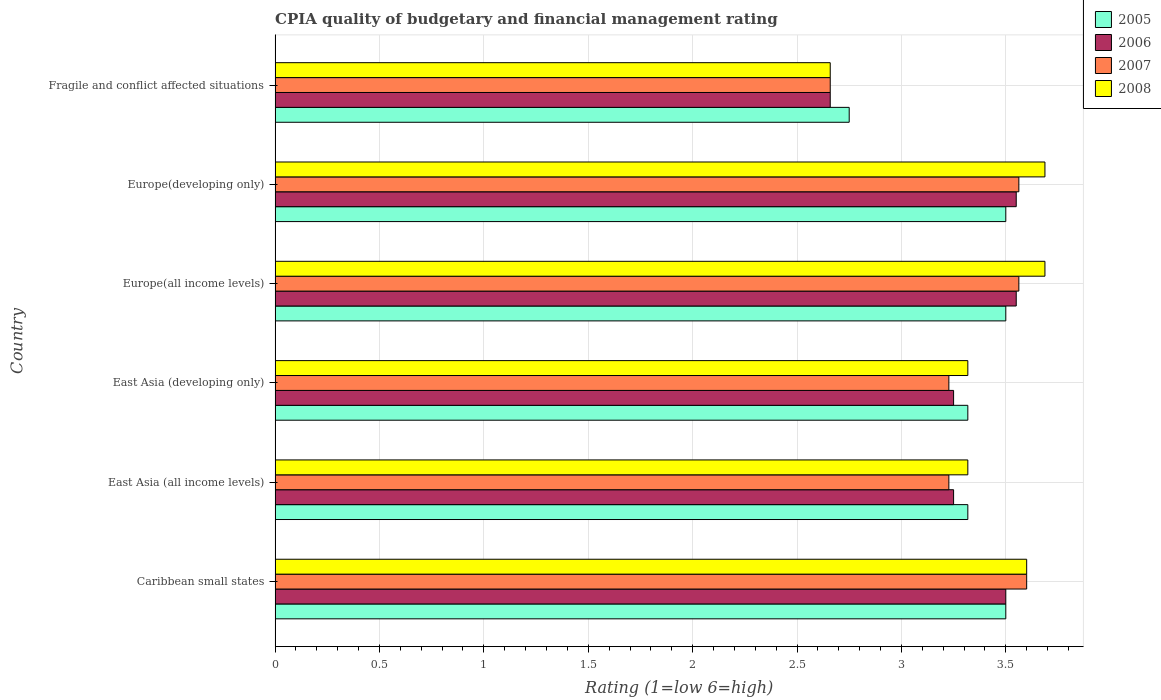How many different coloured bars are there?
Offer a terse response. 4. How many groups of bars are there?
Offer a terse response. 6. Are the number of bars per tick equal to the number of legend labels?
Your answer should be compact. Yes. Are the number of bars on each tick of the Y-axis equal?
Offer a terse response. Yes. How many bars are there on the 1st tick from the top?
Give a very brief answer. 4. How many bars are there on the 4th tick from the bottom?
Offer a terse response. 4. What is the label of the 5th group of bars from the top?
Ensure brevity in your answer.  East Asia (all income levels). What is the CPIA rating in 2005 in Fragile and conflict affected situations?
Provide a short and direct response. 2.75. Across all countries, what is the maximum CPIA rating in 2007?
Provide a short and direct response. 3.6. Across all countries, what is the minimum CPIA rating in 2005?
Your answer should be compact. 2.75. In which country was the CPIA rating in 2005 maximum?
Your response must be concise. Caribbean small states. In which country was the CPIA rating in 2006 minimum?
Keep it short and to the point. Fragile and conflict affected situations. What is the total CPIA rating in 2005 in the graph?
Provide a short and direct response. 19.89. What is the difference between the CPIA rating in 2006 in East Asia (developing only) and that in Fragile and conflict affected situations?
Provide a short and direct response. 0.59. What is the difference between the CPIA rating in 2005 in Europe(developing only) and the CPIA rating in 2008 in Europe(all income levels)?
Offer a terse response. -0.19. What is the average CPIA rating in 2005 per country?
Your answer should be compact. 3.31. What is the difference between the CPIA rating in 2008 and CPIA rating in 2005 in East Asia (all income levels)?
Your answer should be compact. 0. What is the ratio of the CPIA rating in 2008 in Caribbean small states to that in Fragile and conflict affected situations?
Keep it short and to the point. 1.35. Is the CPIA rating in 2005 in Europe(developing only) less than that in Fragile and conflict affected situations?
Give a very brief answer. No. What is the difference between the highest and the second highest CPIA rating in 2006?
Your answer should be very brief. 0. What is the difference between the highest and the lowest CPIA rating in 2008?
Offer a very short reply. 1.03. What does the 1st bar from the bottom in East Asia (all income levels) represents?
Your answer should be compact. 2005. Where does the legend appear in the graph?
Ensure brevity in your answer.  Top right. How many legend labels are there?
Your response must be concise. 4. What is the title of the graph?
Provide a succinct answer. CPIA quality of budgetary and financial management rating. What is the label or title of the Y-axis?
Your answer should be compact. Country. What is the Rating (1=low 6=high) in 2005 in Caribbean small states?
Your response must be concise. 3.5. What is the Rating (1=low 6=high) in 2006 in Caribbean small states?
Offer a terse response. 3.5. What is the Rating (1=low 6=high) in 2005 in East Asia (all income levels)?
Your answer should be very brief. 3.32. What is the Rating (1=low 6=high) in 2007 in East Asia (all income levels)?
Provide a short and direct response. 3.23. What is the Rating (1=low 6=high) in 2008 in East Asia (all income levels)?
Provide a short and direct response. 3.32. What is the Rating (1=low 6=high) of 2005 in East Asia (developing only)?
Ensure brevity in your answer.  3.32. What is the Rating (1=low 6=high) of 2007 in East Asia (developing only)?
Provide a succinct answer. 3.23. What is the Rating (1=low 6=high) of 2008 in East Asia (developing only)?
Offer a very short reply. 3.32. What is the Rating (1=low 6=high) of 2006 in Europe(all income levels)?
Give a very brief answer. 3.55. What is the Rating (1=low 6=high) of 2007 in Europe(all income levels)?
Ensure brevity in your answer.  3.56. What is the Rating (1=low 6=high) of 2008 in Europe(all income levels)?
Give a very brief answer. 3.69. What is the Rating (1=low 6=high) of 2005 in Europe(developing only)?
Give a very brief answer. 3.5. What is the Rating (1=low 6=high) in 2006 in Europe(developing only)?
Ensure brevity in your answer.  3.55. What is the Rating (1=low 6=high) in 2007 in Europe(developing only)?
Your response must be concise. 3.56. What is the Rating (1=low 6=high) of 2008 in Europe(developing only)?
Make the answer very short. 3.69. What is the Rating (1=low 6=high) of 2005 in Fragile and conflict affected situations?
Give a very brief answer. 2.75. What is the Rating (1=low 6=high) in 2006 in Fragile and conflict affected situations?
Your response must be concise. 2.66. What is the Rating (1=low 6=high) in 2007 in Fragile and conflict affected situations?
Offer a very short reply. 2.66. What is the Rating (1=low 6=high) of 2008 in Fragile and conflict affected situations?
Offer a very short reply. 2.66. Across all countries, what is the maximum Rating (1=low 6=high) in 2006?
Make the answer very short. 3.55. Across all countries, what is the maximum Rating (1=low 6=high) of 2008?
Your answer should be compact. 3.69. Across all countries, what is the minimum Rating (1=low 6=high) of 2005?
Offer a terse response. 2.75. Across all countries, what is the minimum Rating (1=low 6=high) of 2006?
Offer a terse response. 2.66. Across all countries, what is the minimum Rating (1=low 6=high) of 2007?
Your answer should be compact. 2.66. Across all countries, what is the minimum Rating (1=low 6=high) in 2008?
Provide a short and direct response. 2.66. What is the total Rating (1=low 6=high) in 2005 in the graph?
Provide a succinct answer. 19.89. What is the total Rating (1=low 6=high) in 2006 in the graph?
Ensure brevity in your answer.  19.76. What is the total Rating (1=low 6=high) in 2007 in the graph?
Ensure brevity in your answer.  19.84. What is the total Rating (1=low 6=high) of 2008 in the graph?
Offer a terse response. 20.27. What is the difference between the Rating (1=low 6=high) of 2005 in Caribbean small states and that in East Asia (all income levels)?
Your response must be concise. 0.18. What is the difference between the Rating (1=low 6=high) in 2007 in Caribbean small states and that in East Asia (all income levels)?
Your answer should be compact. 0.37. What is the difference between the Rating (1=low 6=high) in 2008 in Caribbean small states and that in East Asia (all income levels)?
Ensure brevity in your answer.  0.28. What is the difference between the Rating (1=low 6=high) in 2005 in Caribbean small states and that in East Asia (developing only)?
Keep it short and to the point. 0.18. What is the difference between the Rating (1=low 6=high) of 2007 in Caribbean small states and that in East Asia (developing only)?
Provide a succinct answer. 0.37. What is the difference between the Rating (1=low 6=high) in 2008 in Caribbean small states and that in East Asia (developing only)?
Keep it short and to the point. 0.28. What is the difference between the Rating (1=low 6=high) of 2005 in Caribbean small states and that in Europe(all income levels)?
Your answer should be compact. 0. What is the difference between the Rating (1=low 6=high) of 2006 in Caribbean small states and that in Europe(all income levels)?
Give a very brief answer. -0.05. What is the difference between the Rating (1=low 6=high) in 2007 in Caribbean small states and that in Europe(all income levels)?
Give a very brief answer. 0.04. What is the difference between the Rating (1=low 6=high) in 2008 in Caribbean small states and that in Europe(all income levels)?
Provide a short and direct response. -0.09. What is the difference between the Rating (1=low 6=high) in 2006 in Caribbean small states and that in Europe(developing only)?
Provide a short and direct response. -0.05. What is the difference between the Rating (1=low 6=high) of 2007 in Caribbean small states and that in Europe(developing only)?
Provide a short and direct response. 0.04. What is the difference between the Rating (1=low 6=high) of 2008 in Caribbean small states and that in Europe(developing only)?
Your answer should be compact. -0.09. What is the difference between the Rating (1=low 6=high) in 2006 in Caribbean small states and that in Fragile and conflict affected situations?
Your response must be concise. 0.84. What is the difference between the Rating (1=low 6=high) of 2007 in Caribbean small states and that in Fragile and conflict affected situations?
Offer a terse response. 0.94. What is the difference between the Rating (1=low 6=high) of 2008 in Caribbean small states and that in Fragile and conflict affected situations?
Your answer should be compact. 0.94. What is the difference between the Rating (1=low 6=high) in 2005 in East Asia (all income levels) and that in East Asia (developing only)?
Provide a succinct answer. 0. What is the difference between the Rating (1=low 6=high) in 2005 in East Asia (all income levels) and that in Europe(all income levels)?
Provide a short and direct response. -0.18. What is the difference between the Rating (1=low 6=high) in 2007 in East Asia (all income levels) and that in Europe(all income levels)?
Make the answer very short. -0.34. What is the difference between the Rating (1=low 6=high) in 2008 in East Asia (all income levels) and that in Europe(all income levels)?
Your response must be concise. -0.37. What is the difference between the Rating (1=low 6=high) in 2005 in East Asia (all income levels) and that in Europe(developing only)?
Offer a terse response. -0.18. What is the difference between the Rating (1=low 6=high) in 2006 in East Asia (all income levels) and that in Europe(developing only)?
Offer a terse response. -0.3. What is the difference between the Rating (1=low 6=high) in 2007 in East Asia (all income levels) and that in Europe(developing only)?
Provide a short and direct response. -0.34. What is the difference between the Rating (1=low 6=high) in 2008 in East Asia (all income levels) and that in Europe(developing only)?
Your response must be concise. -0.37. What is the difference between the Rating (1=low 6=high) of 2005 in East Asia (all income levels) and that in Fragile and conflict affected situations?
Offer a very short reply. 0.57. What is the difference between the Rating (1=low 6=high) of 2006 in East Asia (all income levels) and that in Fragile and conflict affected situations?
Offer a very short reply. 0.59. What is the difference between the Rating (1=low 6=high) of 2007 in East Asia (all income levels) and that in Fragile and conflict affected situations?
Keep it short and to the point. 0.57. What is the difference between the Rating (1=low 6=high) of 2008 in East Asia (all income levels) and that in Fragile and conflict affected situations?
Your response must be concise. 0.66. What is the difference between the Rating (1=low 6=high) in 2005 in East Asia (developing only) and that in Europe(all income levels)?
Ensure brevity in your answer.  -0.18. What is the difference between the Rating (1=low 6=high) in 2006 in East Asia (developing only) and that in Europe(all income levels)?
Provide a short and direct response. -0.3. What is the difference between the Rating (1=low 6=high) of 2007 in East Asia (developing only) and that in Europe(all income levels)?
Offer a terse response. -0.34. What is the difference between the Rating (1=low 6=high) in 2008 in East Asia (developing only) and that in Europe(all income levels)?
Provide a succinct answer. -0.37. What is the difference between the Rating (1=low 6=high) in 2005 in East Asia (developing only) and that in Europe(developing only)?
Offer a very short reply. -0.18. What is the difference between the Rating (1=low 6=high) in 2006 in East Asia (developing only) and that in Europe(developing only)?
Make the answer very short. -0.3. What is the difference between the Rating (1=low 6=high) of 2007 in East Asia (developing only) and that in Europe(developing only)?
Provide a succinct answer. -0.34. What is the difference between the Rating (1=low 6=high) in 2008 in East Asia (developing only) and that in Europe(developing only)?
Offer a very short reply. -0.37. What is the difference between the Rating (1=low 6=high) in 2005 in East Asia (developing only) and that in Fragile and conflict affected situations?
Give a very brief answer. 0.57. What is the difference between the Rating (1=low 6=high) of 2006 in East Asia (developing only) and that in Fragile and conflict affected situations?
Provide a short and direct response. 0.59. What is the difference between the Rating (1=low 6=high) of 2007 in East Asia (developing only) and that in Fragile and conflict affected situations?
Offer a very short reply. 0.57. What is the difference between the Rating (1=low 6=high) of 2008 in East Asia (developing only) and that in Fragile and conflict affected situations?
Ensure brevity in your answer.  0.66. What is the difference between the Rating (1=low 6=high) in 2006 in Europe(all income levels) and that in Europe(developing only)?
Your answer should be very brief. 0. What is the difference between the Rating (1=low 6=high) in 2006 in Europe(all income levels) and that in Fragile and conflict affected situations?
Provide a succinct answer. 0.89. What is the difference between the Rating (1=low 6=high) of 2007 in Europe(all income levels) and that in Fragile and conflict affected situations?
Provide a succinct answer. 0.9. What is the difference between the Rating (1=low 6=high) in 2008 in Europe(all income levels) and that in Fragile and conflict affected situations?
Give a very brief answer. 1.03. What is the difference between the Rating (1=low 6=high) in 2006 in Europe(developing only) and that in Fragile and conflict affected situations?
Provide a short and direct response. 0.89. What is the difference between the Rating (1=low 6=high) of 2007 in Europe(developing only) and that in Fragile and conflict affected situations?
Offer a very short reply. 0.9. What is the difference between the Rating (1=low 6=high) of 2008 in Europe(developing only) and that in Fragile and conflict affected situations?
Your answer should be compact. 1.03. What is the difference between the Rating (1=low 6=high) of 2005 in Caribbean small states and the Rating (1=low 6=high) of 2006 in East Asia (all income levels)?
Your answer should be very brief. 0.25. What is the difference between the Rating (1=low 6=high) of 2005 in Caribbean small states and the Rating (1=low 6=high) of 2007 in East Asia (all income levels)?
Ensure brevity in your answer.  0.27. What is the difference between the Rating (1=low 6=high) in 2005 in Caribbean small states and the Rating (1=low 6=high) in 2008 in East Asia (all income levels)?
Provide a succinct answer. 0.18. What is the difference between the Rating (1=low 6=high) in 2006 in Caribbean small states and the Rating (1=low 6=high) in 2007 in East Asia (all income levels)?
Provide a succinct answer. 0.27. What is the difference between the Rating (1=low 6=high) in 2006 in Caribbean small states and the Rating (1=low 6=high) in 2008 in East Asia (all income levels)?
Keep it short and to the point. 0.18. What is the difference between the Rating (1=low 6=high) in 2007 in Caribbean small states and the Rating (1=low 6=high) in 2008 in East Asia (all income levels)?
Keep it short and to the point. 0.28. What is the difference between the Rating (1=low 6=high) in 2005 in Caribbean small states and the Rating (1=low 6=high) in 2006 in East Asia (developing only)?
Offer a terse response. 0.25. What is the difference between the Rating (1=low 6=high) in 2005 in Caribbean small states and the Rating (1=low 6=high) in 2007 in East Asia (developing only)?
Your answer should be compact. 0.27. What is the difference between the Rating (1=low 6=high) in 2005 in Caribbean small states and the Rating (1=low 6=high) in 2008 in East Asia (developing only)?
Provide a succinct answer. 0.18. What is the difference between the Rating (1=low 6=high) of 2006 in Caribbean small states and the Rating (1=low 6=high) of 2007 in East Asia (developing only)?
Ensure brevity in your answer.  0.27. What is the difference between the Rating (1=low 6=high) in 2006 in Caribbean small states and the Rating (1=low 6=high) in 2008 in East Asia (developing only)?
Give a very brief answer. 0.18. What is the difference between the Rating (1=low 6=high) of 2007 in Caribbean small states and the Rating (1=low 6=high) of 2008 in East Asia (developing only)?
Offer a very short reply. 0.28. What is the difference between the Rating (1=low 6=high) of 2005 in Caribbean small states and the Rating (1=low 6=high) of 2007 in Europe(all income levels)?
Offer a very short reply. -0.06. What is the difference between the Rating (1=low 6=high) of 2005 in Caribbean small states and the Rating (1=low 6=high) of 2008 in Europe(all income levels)?
Your response must be concise. -0.19. What is the difference between the Rating (1=low 6=high) of 2006 in Caribbean small states and the Rating (1=low 6=high) of 2007 in Europe(all income levels)?
Your answer should be compact. -0.06. What is the difference between the Rating (1=low 6=high) of 2006 in Caribbean small states and the Rating (1=low 6=high) of 2008 in Europe(all income levels)?
Give a very brief answer. -0.19. What is the difference between the Rating (1=low 6=high) in 2007 in Caribbean small states and the Rating (1=low 6=high) in 2008 in Europe(all income levels)?
Your answer should be very brief. -0.09. What is the difference between the Rating (1=low 6=high) in 2005 in Caribbean small states and the Rating (1=low 6=high) in 2006 in Europe(developing only)?
Offer a very short reply. -0.05. What is the difference between the Rating (1=low 6=high) in 2005 in Caribbean small states and the Rating (1=low 6=high) in 2007 in Europe(developing only)?
Keep it short and to the point. -0.06. What is the difference between the Rating (1=low 6=high) of 2005 in Caribbean small states and the Rating (1=low 6=high) of 2008 in Europe(developing only)?
Ensure brevity in your answer.  -0.19. What is the difference between the Rating (1=low 6=high) in 2006 in Caribbean small states and the Rating (1=low 6=high) in 2007 in Europe(developing only)?
Provide a short and direct response. -0.06. What is the difference between the Rating (1=low 6=high) of 2006 in Caribbean small states and the Rating (1=low 6=high) of 2008 in Europe(developing only)?
Offer a very short reply. -0.19. What is the difference between the Rating (1=low 6=high) of 2007 in Caribbean small states and the Rating (1=low 6=high) of 2008 in Europe(developing only)?
Keep it short and to the point. -0.09. What is the difference between the Rating (1=low 6=high) in 2005 in Caribbean small states and the Rating (1=low 6=high) in 2006 in Fragile and conflict affected situations?
Your response must be concise. 0.84. What is the difference between the Rating (1=low 6=high) of 2005 in Caribbean small states and the Rating (1=low 6=high) of 2007 in Fragile and conflict affected situations?
Provide a short and direct response. 0.84. What is the difference between the Rating (1=low 6=high) of 2005 in Caribbean small states and the Rating (1=low 6=high) of 2008 in Fragile and conflict affected situations?
Provide a short and direct response. 0.84. What is the difference between the Rating (1=low 6=high) in 2006 in Caribbean small states and the Rating (1=low 6=high) in 2007 in Fragile and conflict affected situations?
Keep it short and to the point. 0.84. What is the difference between the Rating (1=low 6=high) in 2006 in Caribbean small states and the Rating (1=low 6=high) in 2008 in Fragile and conflict affected situations?
Offer a very short reply. 0.84. What is the difference between the Rating (1=low 6=high) of 2007 in Caribbean small states and the Rating (1=low 6=high) of 2008 in Fragile and conflict affected situations?
Give a very brief answer. 0.94. What is the difference between the Rating (1=low 6=high) in 2005 in East Asia (all income levels) and the Rating (1=low 6=high) in 2006 in East Asia (developing only)?
Your answer should be very brief. 0.07. What is the difference between the Rating (1=low 6=high) in 2005 in East Asia (all income levels) and the Rating (1=low 6=high) in 2007 in East Asia (developing only)?
Provide a succinct answer. 0.09. What is the difference between the Rating (1=low 6=high) of 2005 in East Asia (all income levels) and the Rating (1=low 6=high) of 2008 in East Asia (developing only)?
Your answer should be very brief. 0. What is the difference between the Rating (1=low 6=high) in 2006 in East Asia (all income levels) and the Rating (1=low 6=high) in 2007 in East Asia (developing only)?
Make the answer very short. 0.02. What is the difference between the Rating (1=low 6=high) in 2006 in East Asia (all income levels) and the Rating (1=low 6=high) in 2008 in East Asia (developing only)?
Provide a succinct answer. -0.07. What is the difference between the Rating (1=low 6=high) of 2007 in East Asia (all income levels) and the Rating (1=low 6=high) of 2008 in East Asia (developing only)?
Provide a short and direct response. -0.09. What is the difference between the Rating (1=low 6=high) of 2005 in East Asia (all income levels) and the Rating (1=low 6=high) of 2006 in Europe(all income levels)?
Your response must be concise. -0.23. What is the difference between the Rating (1=low 6=high) in 2005 in East Asia (all income levels) and the Rating (1=low 6=high) in 2007 in Europe(all income levels)?
Provide a short and direct response. -0.24. What is the difference between the Rating (1=low 6=high) in 2005 in East Asia (all income levels) and the Rating (1=low 6=high) in 2008 in Europe(all income levels)?
Your answer should be compact. -0.37. What is the difference between the Rating (1=low 6=high) of 2006 in East Asia (all income levels) and the Rating (1=low 6=high) of 2007 in Europe(all income levels)?
Provide a short and direct response. -0.31. What is the difference between the Rating (1=low 6=high) of 2006 in East Asia (all income levels) and the Rating (1=low 6=high) of 2008 in Europe(all income levels)?
Provide a short and direct response. -0.44. What is the difference between the Rating (1=low 6=high) in 2007 in East Asia (all income levels) and the Rating (1=low 6=high) in 2008 in Europe(all income levels)?
Offer a terse response. -0.46. What is the difference between the Rating (1=low 6=high) in 2005 in East Asia (all income levels) and the Rating (1=low 6=high) in 2006 in Europe(developing only)?
Provide a succinct answer. -0.23. What is the difference between the Rating (1=low 6=high) in 2005 in East Asia (all income levels) and the Rating (1=low 6=high) in 2007 in Europe(developing only)?
Your answer should be compact. -0.24. What is the difference between the Rating (1=low 6=high) of 2005 in East Asia (all income levels) and the Rating (1=low 6=high) of 2008 in Europe(developing only)?
Ensure brevity in your answer.  -0.37. What is the difference between the Rating (1=low 6=high) of 2006 in East Asia (all income levels) and the Rating (1=low 6=high) of 2007 in Europe(developing only)?
Make the answer very short. -0.31. What is the difference between the Rating (1=low 6=high) in 2006 in East Asia (all income levels) and the Rating (1=low 6=high) in 2008 in Europe(developing only)?
Your answer should be compact. -0.44. What is the difference between the Rating (1=low 6=high) of 2007 in East Asia (all income levels) and the Rating (1=low 6=high) of 2008 in Europe(developing only)?
Ensure brevity in your answer.  -0.46. What is the difference between the Rating (1=low 6=high) of 2005 in East Asia (all income levels) and the Rating (1=low 6=high) of 2006 in Fragile and conflict affected situations?
Your answer should be very brief. 0.66. What is the difference between the Rating (1=low 6=high) in 2005 in East Asia (all income levels) and the Rating (1=low 6=high) in 2007 in Fragile and conflict affected situations?
Offer a very short reply. 0.66. What is the difference between the Rating (1=low 6=high) of 2005 in East Asia (all income levels) and the Rating (1=low 6=high) of 2008 in Fragile and conflict affected situations?
Your response must be concise. 0.66. What is the difference between the Rating (1=low 6=high) in 2006 in East Asia (all income levels) and the Rating (1=low 6=high) in 2007 in Fragile and conflict affected situations?
Give a very brief answer. 0.59. What is the difference between the Rating (1=low 6=high) of 2006 in East Asia (all income levels) and the Rating (1=low 6=high) of 2008 in Fragile and conflict affected situations?
Give a very brief answer. 0.59. What is the difference between the Rating (1=low 6=high) in 2007 in East Asia (all income levels) and the Rating (1=low 6=high) in 2008 in Fragile and conflict affected situations?
Your answer should be compact. 0.57. What is the difference between the Rating (1=low 6=high) in 2005 in East Asia (developing only) and the Rating (1=low 6=high) in 2006 in Europe(all income levels)?
Provide a succinct answer. -0.23. What is the difference between the Rating (1=low 6=high) of 2005 in East Asia (developing only) and the Rating (1=low 6=high) of 2007 in Europe(all income levels)?
Provide a succinct answer. -0.24. What is the difference between the Rating (1=low 6=high) of 2005 in East Asia (developing only) and the Rating (1=low 6=high) of 2008 in Europe(all income levels)?
Offer a very short reply. -0.37. What is the difference between the Rating (1=low 6=high) of 2006 in East Asia (developing only) and the Rating (1=low 6=high) of 2007 in Europe(all income levels)?
Your response must be concise. -0.31. What is the difference between the Rating (1=low 6=high) in 2006 in East Asia (developing only) and the Rating (1=low 6=high) in 2008 in Europe(all income levels)?
Your response must be concise. -0.44. What is the difference between the Rating (1=low 6=high) in 2007 in East Asia (developing only) and the Rating (1=low 6=high) in 2008 in Europe(all income levels)?
Make the answer very short. -0.46. What is the difference between the Rating (1=low 6=high) of 2005 in East Asia (developing only) and the Rating (1=low 6=high) of 2006 in Europe(developing only)?
Offer a very short reply. -0.23. What is the difference between the Rating (1=low 6=high) in 2005 in East Asia (developing only) and the Rating (1=low 6=high) in 2007 in Europe(developing only)?
Give a very brief answer. -0.24. What is the difference between the Rating (1=low 6=high) of 2005 in East Asia (developing only) and the Rating (1=low 6=high) of 2008 in Europe(developing only)?
Provide a succinct answer. -0.37. What is the difference between the Rating (1=low 6=high) of 2006 in East Asia (developing only) and the Rating (1=low 6=high) of 2007 in Europe(developing only)?
Offer a very short reply. -0.31. What is the difference between the Rating (1=low 6=high) of 2006 in East Asia (developing only) and the Rating (1=low 6=high) of 2008 in Europe(developing only)?
Give a very brief answer. -0.44. What is the difference between the Rating (1=low 6=high) of 2007 in East Asia (developing only) and the Rating (1=low 6=high) of 2008 in Europe(developing only)?
Provide a short and direct response. -0.46. What is the difference between the Rating (1=low 6=high) in 2005 in East Asia (developing only) and the Rating (1=low 6=high) in 2006 in Fragile and conflict affected situations?
Provide a short and direct response. 0.66. What is the difference between the Rating (1=low 6=high) of 2005 in East Asia (developing only) and the Rating (1=low 6=high) of 2007 in Fragile and conflict affected situations?
Provide a succinct answer. 0.66. What is the difference between the Rating (1=low 6=high) in 2005 in East Asia (developing only) and the Rating (1=low 6=high) in 2008 in Fragile and conflict affected situations?
Make the answer very short. 0.66. What is the difference between the Rating (1=low 6=high) of 2006 in East Asia (developing only) and the Rating (1=low 6=high) of 2007 in Fragile and conflict affected situations?
Provide a short and direct response. 0.59. What is the difference between the Rating (1=low 6=high) of 2006 in East Asia (developing only) and the Rating (1=low 6=high) of 2008 in Fragile and conflict affected situations?
Your answer should be compact. 0.59. What is the difference between the Rating (1=low 6=high) of 2007 in East Asia (developing only) and the Rating (1=low 6=high) of 2008 in Fragile and conflict affected situations?
Make the answer very short. 0.57. What is the difference between the Rating (1=low 6=high) in 2005 in Europe(all income levels) and the Rating (1=low 6=high) in 2007 in Europe(developing only)?
Keep it short and to the point. -0.06. What is the difference between the Rating (1=low 6=high) of 2005 in Europe(all income levels) and the Rating (1=low 6=high) of 2008 in Europe(developing only)?
Make the answer very short. -0.19. What is the difference between the Rating (1=low 6=high) of 2006 in Europe(all income levels) and the Rating (1=low 6=high) of 2007 in Europe(developing only)?
Give a very brief answer. -0.01. What is the difference between the Rating (1=low 6=high) in 2006 in Europe(all income levels) and the Rating (1=low 6=high) in 2008 in Europe(developing only)?
Provide a succinct answer. -0.14. What is the difference between the Rating (1=low 6=high) of 2007 in Europe(all income levels) and the Rating (1=low 6=high) of 2008 in Europe(developing only)?
Your answer should be compact. -0.12. What is the difference between the Rating (1=low 6=high) of 2005 in Europe(all income levels) and the Rating (1=low 6=high) of 2006 in Fragile and conflict affected situations?
Offer a very short reply. 0.84. What is the difference between the Rating (1=low 6=high) in 2005 in Europe(all income levels) and the Rating (1=low 6=high) in 2007 in Fragile and conflict affected situations?
Give a very brief answer. 0.84. What is the difference between the Rating (1=low 6=high) in 2005 in Europe(all income levels) and the Rating (1=low 6=high) in 2008 in Fragile and conflict affected situations?
Your answer should be compact. 0.84. What is the difference between the Rating (1=low 6=high) of 2006 in Europe(all income levels) and the Rating (1=low 6=high) of 2007 in Fragile and conflict affected situations?
Offer a very short reply. 0.89. What is the difference between the Rating (1=low 6=high) of 2006 in Europe(all income levels) and the Rating (1=low 6=high) of 2008 in Fragile and conflict affected situations?
Your response must be concise. 0.89. What is the difference between the Rating (1=low 6=high) of 2007 in Europe(all income levels) and the Rating (1=low 6=high) of 2008 in Fragile and conflict affected situations?
Provide a succinct answer. 0.9. What is the difference between the Rating (1=low 6=high) in 2005 in Europe(developing only) and the Rating (1=low 6=high) in 2006 in Fragile and conflict affected situations?
Keep it short and to the point. 0.84. What is the difference between the Rating (1=low 6=high) in 2005 in Europe(developing only) and the Rating (1=low 6=high) in 2007 in Fragile and conflict affected situations?
Give a very brief answer. 0.84. What is the difference between the Rating (1=low 6=high) of 2005 in Europe(developing only) and the Rating (1=low 6=high) of 2008 in Fragile and conflict affected situations?
Your response must be concise. 0.84. What is the difference between the Rating (1=low 6=high) of 2006 in Europe(developing only) and the Rating (1=low 6=high) of 2007 in Fragile and conflict affected situations?
Offer a terse response. 0.89. What is the difference between the Rating (1=low 6=high) in 2006 in Europe(developing only) and the Rating (1=low 6=high) in 2008 in Fragile and conflict affected situations?
Your response must be concise. 0.89. What is the difference between the Rating (1=low 6=high) in 2007 in Europe(developing only) and the Rating (1=low 6=high) in 2008 in Fragile and conflict affected situations?
Give a very brief answer. 0.9. What is the average Rating (1=low 6=high) of 2005 per country?
Your response must be concise. 3.31. What is the average Rating (1=low 6=high) in 2006 per country?
Provide a succinct answer. 3.29. What is the average Rating (1=low 6=high) of 2007 per country?
Your answer should be compact. 3.31. What is the average Rating (1=low 6=high) in 2008 per country?
Your answer should be compact. 3.38. What is the difference between the Rating (1=low 6=high) in 2005 and Rating (1=low 6=high) in 2006 in Caribbean small states?
Provide a succinct answer. 0. What is the difference between the Rating (1=low 6=high) in 2005 and Rating (1=low 6=high) in 2007 in Caribbean small states?
Provide a succinct answer. -0.1. What is the difference between the Rating (1=low 6=high) of 2005 and Rating (1=low 6=high) of 2008 in Caribbean small states?
Your response must be concise. -0.1. What is the difference between the Rating (1=low 6=high) of 2006 and Rating (1=low 6=high) of 2007 in Caribbean small states?
Provide a succinct answer. -0.1. What is the difference between the Rating (1=low 6=high) of 2005 and Rating (1=low 6=high) of 2006 in East Asia (all income levels)?
Give a very brief answer. 0.07. What is the difference between the Rating (1=low 6=high) in 2005 and Rating (1=low 6=high) in 2007 in East Asia (all income levels)?
Your answer should be very brief. 0.09. What is the difference between the Rating (1=low 6=high) of 2006 and Rating (1=low 6=high) of 2007 in East Asia (all income levels)?
Your response must be concise. 0.02. What is the difference between the Rating (1=low 6=high) in 2006 and Rating (1=low 6=high) in 2008 in East Asia (all income levels)?
Keep it short and to the point. -0.07. What is the difference between the Rating (1=low 6=high) in 2007 and Rating (1=low 6=high) in 2008 in East Asia (all income levels)?
Provide a short and direct response. -0.09. What is the difference between the Rating (1=low 6=high) in 2005 and Rating (1=low 6=high) in 2006 in East Asia (developing only)?
Make the answer very short. 0.07. What is the difference between the Rating (1=low 6=high) in 2005 and Rating (1=low 6=high) in 2007 in East Asia (developing only)?
Your answer should be compact. 0.09. What is the difference between the Rating (1=low 6=high) of 2006 and Rating (1=low 6=high) of 2007 in East Asia (developing only)?
Offer a very short reply. 0.02. What is the difference between the Rating (1=low 6=high) of 2006 and Rating (1=low 6=high) of 2008 in East Asia (developing only)?
Provide a short and direct response. -0.07. What is the difference between the Rating (1=low 6=high) of 2007 and Rating (1=low 6=high) of 2008 in East Asia (developing only)?
Offer a terse response. -0.09. What is the difference between the Rating (1=low 6=high) in 2005 and Rating (1=low 6=high) in 2007 in Europe(all income levels)?
Give a very brief answer. -0.06. What is the difference between the Rating (1=low 6=high) in 2005 and Rating (1=low 6=high) in 2008 in Europe(all income levels)?
Your response must be concise. -0.19. What is the difference between the Rating (1=low 6=high) in 2006 and Rating (1=low 6=high) in 2007 in Europe(all income levels)?
Provide a short and direct response. -0.01. What is the difference between the Rating (1=low 6=high) of 2006 and Rating (1=low 6=high) of 2008 in Europe(all income levels)?
Give a very brief answer. -0.14. What is the difference between the Rating (1=low 6=high) in 2007 and Rating (1=low 6=high) in 2008 in Europe(all income levels)?
Your answer should be very brief. -0.12. What is the difference between the Rating (1=low 6=high) of 2005 and Rating (1=low 6=high) of 2006 in Europe(developing only)?
Your answer should be compact. -0.05. What is the difference between the Rating (1=low 6=high) of 2005 and Rating (1=low 6=high) of 2007 in Europe(developing only)?
Give a very brief answer. -0.06. What is the difference between the Rating (1=low 6=high) in 2005 and Rating (1=low 6=high) in 2008 in Europe(developing only)?
Your response must be concise. -0.19. What is the difference between the Rating (1=low 6=high) in 2006 and Rating (1=low 6=high) in 2007 in Europe(developing only)?
Offer a terse response. -0.01. What is the difference between the Rating (1=low 6=high) of 2006 and Rating (1=low 6=high) of 2008 in Europe(developing only)?
Provide a short and direct response. -0.14. What is the difference between the Rating (1=low 6=high) in 2007 and Rating (1=low 6=high) in 2008 in Europe(developing only)?
Make the answer very short. -0.12. What is the difference between the Rating (1=low 6=high) of 2005 and Rating (1=low 6=high) of 2006 in Fragile and conflict affected situations?
Provide a succinct answer. 0.09. What is the difference between the Rating (1=low 6=high) in 2005 and Rating (1=low 6=high) in 2007 in Fragile and conflict affected situations?
Provide a short and direct response. 0.09. What is the difference between the Rating (1=low 6=high) of 2005 and Rating (1=low 6=high) of 2008 in Fragile and conflict affected situations?
Your answer should be very brief. 0.09. What is the difference between the Rating (1=low 6=high) in 2006 and Rating (1=low 6=high) in 2007 in Fragile and conflict affected situations?
Offer a terse response. 0. What is the difference between the Rating (1=low 6=high) of 2006 and Rating (1=low 6=high) of 2008 in Fragile and conflict affected situations?
Offer a terse response. 0. What is the ratio of the Rating (1=low 6=high) in 2005 in Caribbean small states to that in East Asia (all income levels)?
Provide a short and direct response. 1.05. What is the ratio of the Rating (1=low 6=high) of 2007 in Caribbean small states to that in East Asia (all income levels)?
Give a very brief answer. 1.12. What is the ratio of the Rating (1=low 6=high) in 2008 in Caribbean small states to that in East Asia (all income levels)?
Provide a succinct answer. 1.08. What is the ratio of the Rating (1=low 6=high) in 2005 in Caribbean small states to that in East Asia (developing only)?
Provide a succinct answer. 1.05. What is the ratio of the Rating (1=low 6=high) in 2006 in Caribbean small states to that in East Asia (developing only)?
Your answer should be very brief. 1.08. What is the ratio of the Rating (1=low 6=high) in 2007 in Caribbean small states to that in East Asia (developing only)?
Offer a terse response. 1.12. What is the ratio of the Rating (1=low 6=high) in 2008 in Caribbean small states to that in East Asia (developing only)?
Provide a short and direct response. 1.08. What is the ratio of the Rating (1=low 6=high) in 2006 in Caribbean small states to that in Europe(all income levels)?
Your response must be concise. 0.99. What is the ratio of the Rating (1=low 6=high) in 2007 in Caribbean small states to that in Europe(all income levels)?
Your answer should be very brief. 1.01. What is the ratio of the Rating (1=low 6=high) in 2008 in Caribbean small states to that in Europe(all income levels)?
Keep it short and to the point. 0.98. What is the ratio of the Rating (1=low 6=high) in 2005 in Caribbean small states to that in Europe(developing only)?
Keep it short and to the point. 1. What is the ratio of the Rating (1=low 6=high) in 2006 in Caribbean small states to that in Europe(developing only)?
Your answer should be compact. 0.99. What is the ratio of the Rating (1=low 6=high) in 2007 in Caribbean small states to that in Europe(developing only)?
Provide a succinct answer. 1.01. What is the ratio of the Rating (1=low 6=high) of 2008 in Caribbean small states to that in Europe(developing only)?
Offer a very short reply. 0.98. What is the ratio of the Rating (1=low 6=high) in 2005 in Caribbean small states to that in Fragile and conflict affected situations?
Offer a very short reply. 1.27. What is the ratio of the Rating (1=low 6=high) in 2006 in Caribbean small states to that in Fragile and conflict affected situations?
Make the answer very short. 1.32. What is the ratio of the Rating (1=low 6=high) in 2007 in Caribbean small states to that in Fragile and conflict affected situations?
Offer a terse response. 1.35. What is the ratio of the Rating (1=low 6=high) of 2008 in Caribbean small states to that in Fragile and conflict affected situations?
Offer a very short reply. 1.35. What is the ratio of the Rating (1=low 6=high) in 2008 in East Asia (all income levels) to that in East Asia (developing only)?
Your response must be concise. 1. What is the ratio of the Rating (1=low 6=high) of 2005 in East Asia (all income levels) to that in Europe(all income levels)?
Offer a very short reply. 0.95. What is the ratio of the Rating (1=low 6=high) in 2006 in East Asia (all income levels) to that in Europe(all income levels)?
Offer a very short reply. 0.92. What is the ratio of the Rating (1=low 6=high) of 2007 in East Asia (all income levels) to that in Europe(all income levels)?
Make the answer very short. 0.91. What is the ratio of the Rating (1=low 6=high) of 2008 in East Asia (all income levels) to that in Europe(all income levels)?
Offer a very short reply. 0.9. What is the ratio of the Rating (1=low 6=high) in 2005 in East Asia (all income levels) to that in Europe(developing only)?
Provide a short and direct response. 0.95. What is the ratio of the Rating (1=low 6=high) in 2006 in East Asia (all income levels) to that in Europe(developing only)?
Ensure brevity in your answer.  0.92. What is the ratio of the Rating (1=low 6=high) in 2007 in East Asia (all income levels) to that in Europe(developing only)?
Give a very brief answer. 0.91. What is the ratio of the Rating (1=low 6=high) in 2008 in East Asia (all income levels) to that in Europe(developing only)?
Your answer should be compact. 0.9. What is the ratio of the Rating (1=low 6=high) in 2005 in East Asia (all income levels) to that in Fragile and conflict affected situations?
Offer a terse response. 1.21. What is the ratio of the Rating (1=low 6=high) in 2006 in East Asia (all income levels) to that in Fragile and conflict affected situations?
Keep it short and to the point. 1.22. What is the ratio of the Rating (1=low 6=high) of 2007 in East Asia (all income levels) to that in Fragile and conflict affected situations?
Offer a terse response. 1.21. What is the ratio of the Rating (1=low 6=high) of 2008 in East Asia (all income levels) to that in Fragile and conflict affected situations?
Provide a succinct answer. 1.25. What is the ratio of the Rating (1=low 6=high) in 2005 in East Asia (developing only) to that in Europe(all income levels)?
Ensure brevity in your answer.  0.95. What is the ratio of the Rating (1=low 6=high) in 2006 in East Asia (developing only) to that in Europe(all income levels)?
Ensure brevity in your answer.  0.92. What is the ratio of the Rating (1=low 6=high) of 2007 in East Asia (developing only) to that in Europe(all income levels)?
Give a very brief answer. 0.91. What is the ratio of the Rating (1=low 6=high) in 2008 in East Asia (developing only) to that in Europe(all income levels)?
Your answer should be very brief. 0.9. What is the ratio of the Rating (1=low 6=high) of 2005 in East Asia (developing only) to that in Europe(developing only)?
Make the answer very short. 0.95. What is the ratio of the Rating (1=low 6=high) of 2006 in East Asia (developing only) to that in Europe(developing only)?
Offer a terse response. 0.92. What is the ratio of the Rating (1=low 6=high) in 2007 in East Asia (developing only) to that in Europe(developing only)?
Ensure brevity in your answer.  0.91. What is the ratio of the Rating (1=low 6=high) of 2008 in East Asia (developing only) to that in Europe(developing only)?
Offer a terse response. 0.9. What is the ratio of the Rating (1=low 6=high) of 2005 in East Asia (developing only) to that in Fragile and conflict affected situations?
Make the answer very short. 1.21. What is the ratio of the Rating (1=low 6=high) in 2006 in East Asia (developing only) to that in Fragile and conflict affected situations?
Your answer should be very brief. 1.22. What is the ratio of the Rating (1=low 6=high) in 2007 in East Asia (developing only) to that in Fragile and conflict affected situations?
Offer a terse response. 1.21. What is the ratio of the Rating (1=low 6=high) in 2008 in East Asia (developing only) to that in Fragile and conflict affected situations?
Keep it short and to the point. 1.25. What is the ratio of the Rating (1=low 6=high) in 2006 in Europe(all income levels) to that in Europe(developing only)?
Your answer should be compact. 1. What is the ratio of the Rating (1=low 6=high) of 2007 in Europe(all income levels) to that in Europe(developing only)?
Make the answer very short. 1. What is the ratio of the Rating (1=low 6=high) of 2005 in Europe(all income levels) to that in Fragile and conflict affected situations?
Give a very brief answer. 1.27. What is the ratio of the Rating (1=low 6=high) in 2006 in Europe(all income levels) to that in Fragile and conflict affected situations?
Keep it short and to the point. 1.33. What is the ratio of the Rating (1=low 6=high) of 2007 in Europe(all income levels) to that in Fragile and conflict affected situations?
Offer a terse response. 1.34. What is the ratio of the Rating (1=low 6=high) of 2008 in Europe(all income levels) to that in Fragile and conflict affected situations?
Ensure brevity in your answer.  1.39. What is the ratio of the Rating (1=low 6=high) in 2005 in Europe(developing only) to that in Fragile and conflict affected situations?
Keep it short and to the point. 1.27. What is the ratio of the Rating (1=low 6=high) in 2006 in Europe(developing only) to that in Fragile and conflict affected situations?
Make the answer very short. 1.33. What is the ratio of the Rating (1=low 6=high) in 2007 in Europe(developing only) to that in Fragile and conflict affected situations?
Ensure brevity in your answer.  1.34. What is the ratio of the Rating (1=low 6=high) of 2008 in Europe(developing only) to that in Fragile and conflict affected situations?
Your response must be concise. 1.39. What is the difference between the highest and the second highest Rating (1=low 6=high) in 2005?
Your response must be concise. 0. What is the difference between the highest and the second highest Rating (1=low 6=high) in 2007?
Offer a very short reply. 0.04. What is the difference between the highest and the second highest Rating (1=low 6=high) in 2008?
Offer a terse response. 0. What is the difference between the highest and the lowest Rating (1=low 6=high) of 2005?
Ensure brevity in your answer.  0.75. What is the difference between the highest and the lowest Rating (1=low 6=high) of 2006?
Your response must be concise. 0.89. What is the difference between the highest and the lowest Rating (1=low 6=high) in 2007?
Provide a short and direct response. 0.94. What is the difference between the highest and the lowest Rating (1=low 6=high) of 2008?
Keep it short and to the point. 1.03. 